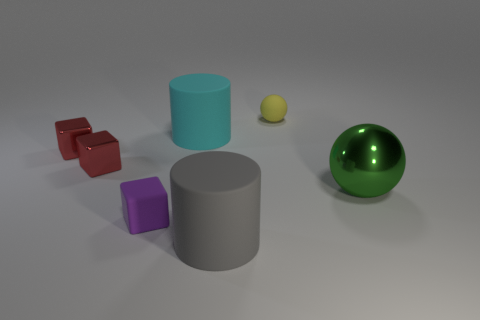Are any green shiny balls visible?
Offer a terse response. Yes. There is a gray object that is the same material as the tiny purple object; what is its size?
Your response must be concise. Large. Is there a small matte cylinder of the same color as the big metal thing?
Ensure brevity in your answer.  No. There is a tiny matte object that is in front of the green shiny thing; does it have the same color as the rubber cylinder that is in front of the tiny purple object?
Offer a very short reply. No. Is there a big green sphere that has the same material as the small yellow object?
Your answer should be very brief. No. What color is the matte sphere?
Your answer should be very brief. Yellow. What size is the green sphere on the right side of the tiny thing right of the rubber cylinder that is on the right side of the cyan matte cylinder?
Ensure brevity in your answer.  Large. How many other things are the same shape as the purple object?
Give a very brief answer. 2. What color is the object that is right of the gray cylinder and in front of the matte ball?
Offer a very short reply. Green. Is there anything else that is the same size as the cyan thing?
Make the answer very short. Yes. 